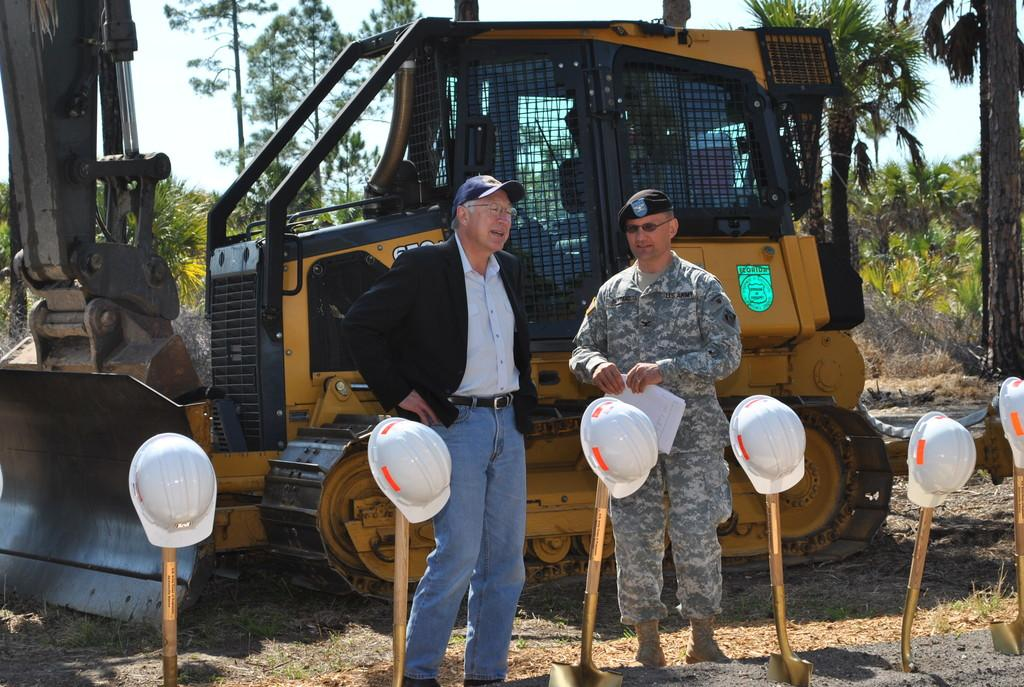What objects are on poles in the image? There are helmets on poles in the image. How are the helmets arranged on the poles? The helmets are arranged from left to right on the poles. What can be seen on the path in the image? There is a vehicle on a path in the image. What type of vegetation is visible in the background of the image? There are plants and trees in the background of the image. Reasoning: Let' Let's think step by step in order to produce the conversation. We start by identifying the main subject in the image, which is the helmets on poles. Then, we describe the arrangement of the helmets to provide more detail. Next, we mention the vehicle on the path as another important element in the image. Finally, we describe the background vegetation to give a sense of the setting. Absurd Question/Answer: What type of leather is visible on the helmets in the image? There is no leather visible on the helmets in the image; they are made of other materials. How many leaves can be seen on the trees in the image? There is no specific mention of leaves on the trees in the image, so it is not possible to determine the number of leaves. 